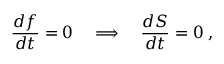Convert formula to latex. <formula><loc_0><loc_0><loc_500><loc_500>\frac { d f } { d t } = 0 \quad \Longrightarrow \quad \frac { d S } { d t } = 0 \, ,</formula> 